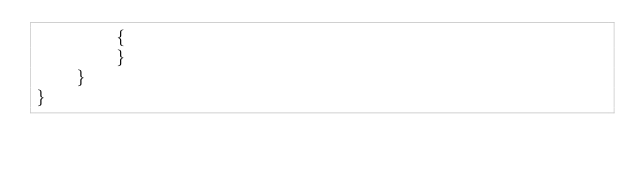Convert code to text. <code><loc_0><loc_0><loc_500><loc_500><_C#_>        {
        }
    }
}</code> 